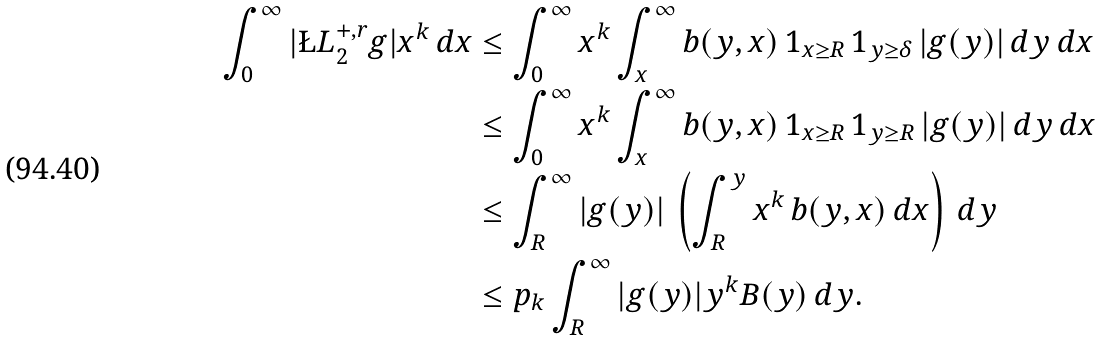Convert formula to latex. <formula><loc_0><loc_0><loc_500><loc_500>\int _ { 0 } ^ { \infty } | \L L _ { 2 } ^ { + , r } g | x ^ { k } \, d x & \leq \int _ { 0 } ^ { \infty } x ^ { k } \int _ { x } ^ { \infty } b ( y , x ) \, { 1 } _ { x \geq R } \, { 1 } _ { y \geq \delta } \, | g ( y ) | \, d y \, d x \\ & \leq \int _ { 0 } ^ { \infty } x ^ { k } \int _ { x } ^ { \infty } b ( y , x ) \, { 1 } _ { x \geq R } \, { 1 } _ { y \geq R } \, | g ( y ) | \, d y \, d x \\ & \leq \int _ { R } ^ { \infty } | g ( y ) | \, \left ( \int _ { R } ^ { y } x ^ { k } \, b ( y , x ) \, d x \right ) \, d y \\ & \leq p _ { k } \int _ { R } ^ { \infty } | g ( y ) | y ^ { k } B ( y ) \, d y .</formula> 